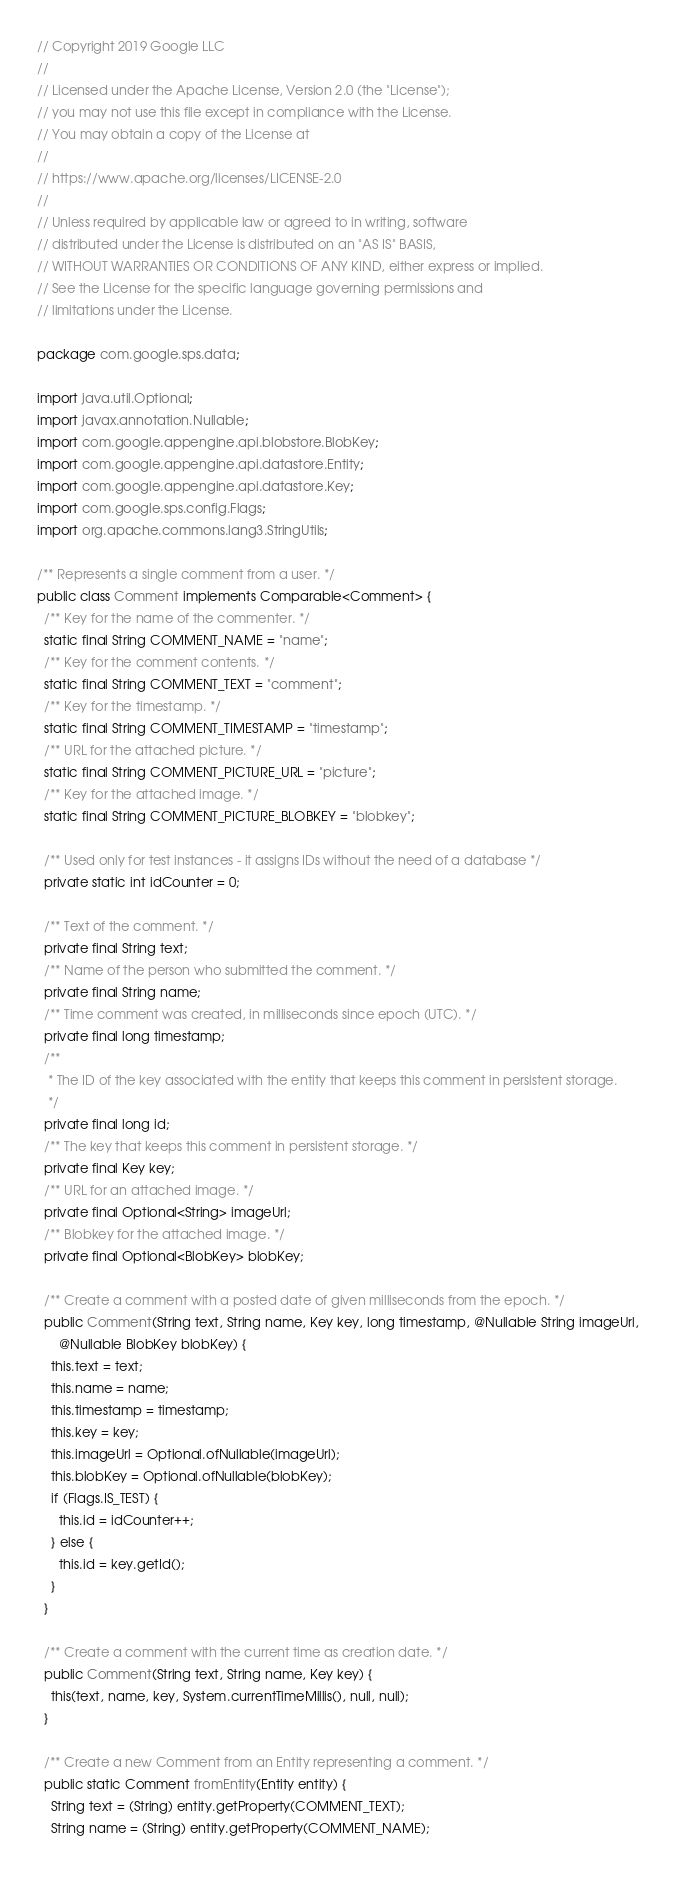<code> <loc_0><loc_0><loc_500><loc_500><_Java_>// Copyright 2019 Google LLC
//
// Licensed under the Apache License, Version 2.0 (the "License");
// you may not use this file except in compliance with the License.
// You may obtain a copy of the License at
//
// https://www.apache.org/licenses/LICENSE-2.0
//
// Unless required by applicable law or agreed to in writing, software
// distributed under the License is distributed on an "AS IS" BASIS,
// WITHOUT WARRANTIES OR CONDITIONS OF ANY KIND, either express or implied.
// See the License for the specific language governing permissions and
// limitations under the License.

package com.google.sps.data;

import java.util.Optional;
import javax.annotation.Nullable;
import com.google.appengine.api.blobstore.BlobKey;
import com.google.appengine.api.datastore.Entity;
import com.google.appengine.api.datastore.Key;
import com.google.sps.config.Flags;
import org.apache.commons.lang3.StringUtils;

/** Represents a single comment from a user. */
public class Comment implements Comparable<Comment> {
  /** Key for the name of the commenter. */
  static final String COMMENT_NAME = "name";
  /** Key for the comment contents. */
  static final String COMMENT_TEXT = "comment";
  /** Key for the timestamp. */
  static final String COMMENT_TIMESTAMP = "timestamp";
  /** URL for the attached picture. */
  static final String COMMENT_PICTURE_URL = "picture";
  /** Key for the attached image. */
  static final String COMMENT_PICTURE_BLOBKEY = "blobkey";

  /** Used only for test instances - it assigns IDs without the need of a database */
  private static int idCounter = 0;

  /** Text of the comment. */
  private final String text;
  /** Name of the person who submitted the comment. */
  private final String name;
  /** Time comment was created, in milliseconds since epoch (UTC). */
  private final long timestamp;
  /**
   * The ID of the key associated with the entity that keeps this comment in persistent storage.
   */
  private final long id;
  /** The key that keeps this comment in persistent storage. */
  private final Key key;
  /** URL for an attached image. */
  private final Optional<String> imageUrl;
  /** Blobkey for the attached image. */
  private final Optional<BlobKey> blobKey;

  /** Create a comment with a posted date of given milliseconds from the epoch. */
  public Comment(String text, String name, Key key, long timestamp, @Nullable String imageUrl,
      @Nullable BlobKey blobKey) {
    this.text = text;
    this.name = name;
    this.timestamp = timestamp;
    this.key = key;
    this.imageUrl = Optional.ofNullable(imageUrl);
    this.blobKey = Optional.ofNullable(blobKey);
    if (Flags.IS_TEST) {
      this.id = idCounter++;
    } else {
      this.id = key.getId();
    }
  }

  /** Create a comment with the current time as creation date. */
  public Comment(String text, String name, Key key) {
    this(text, name, key, System.currentTimeMillis(), null, null);
  }

  /** Create a new Comment from an Entity representing a comment. */
  public static Comment fromEntity(Entity entity) {
    String text = (String) entity.getProperty(COMMENT_TEXT);
    String name = (String) entity.getProperty(COMMENT_NAME);</code> 